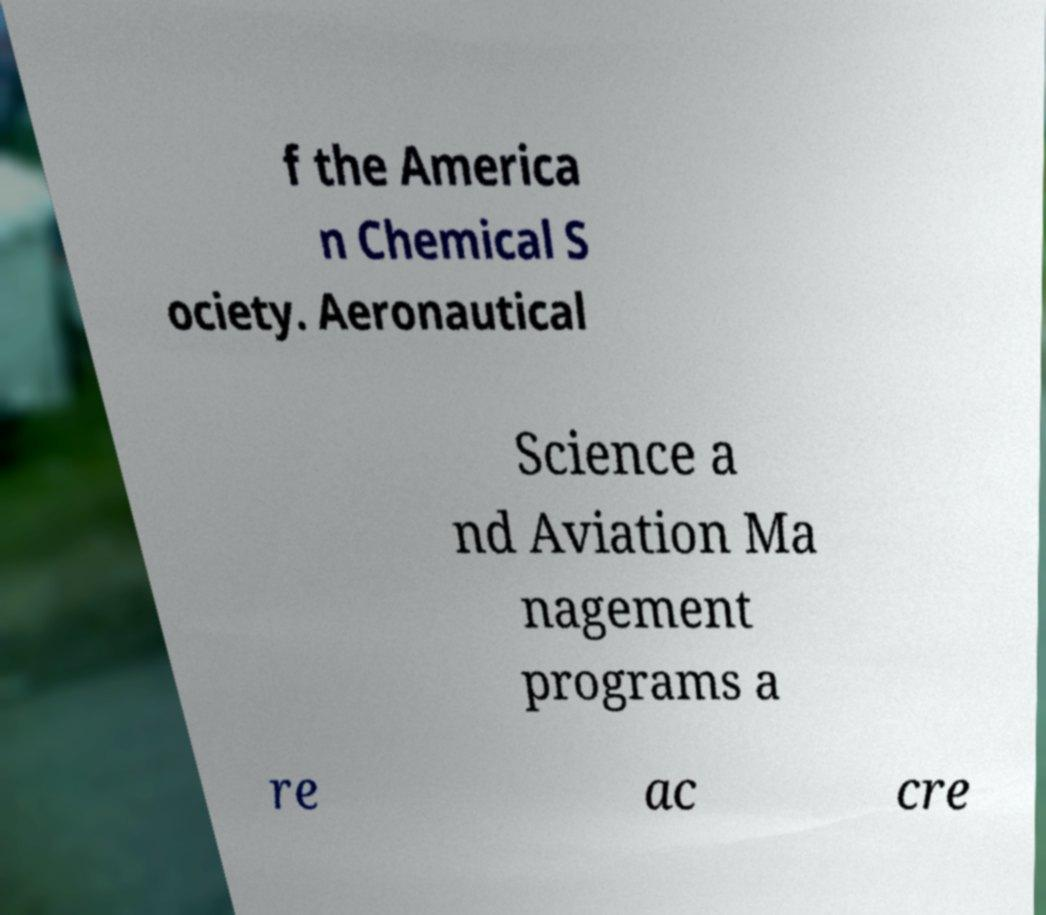Can you accurately transcribe the text from the provided image for me? f the America n Chemical S ociety. Aeronautical Science a nd Aviation Ma nagement programs a re ac cre 